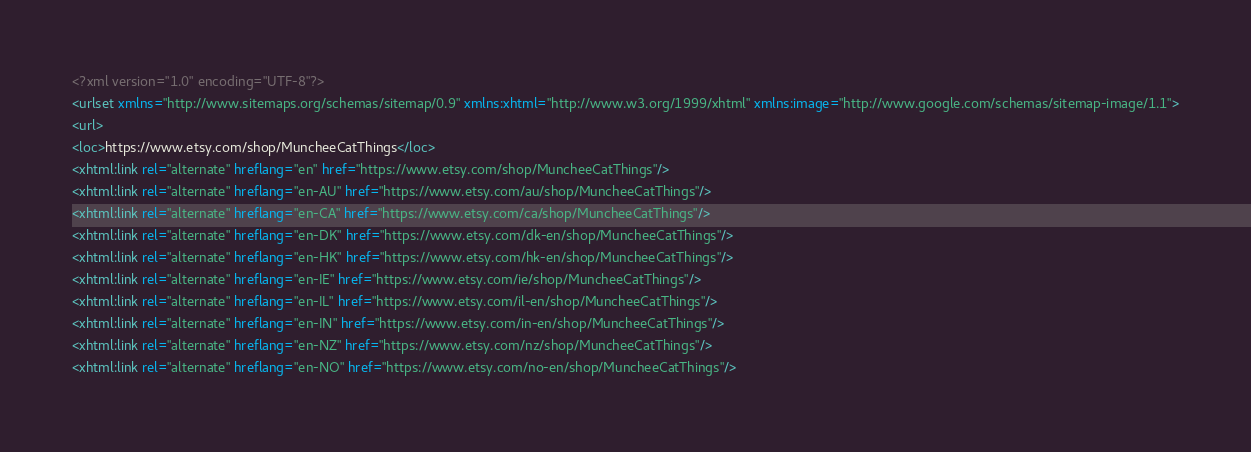Convert code to text. <code><loc_0><loc_0><loc_500><loc_500><_XML_><?xml version="1.0" encoding="UTF-8"?>
<urlset xmlns="http://www.sitemaps.org/schemas/sitemap/0.9" xmlns:xhtml="http://www.w3.org/1999/xhtml" xmlns:image="http://www.google.com/schemas/sitemap-image/1.1">
<url>
<loc>https://www.etsy.com/shop/MuncheeCatThings</loc>
<xhtml:link rel="alternate" hreflang="en" href="https://www.etsy.com/shop/MuncheeCatThings"/>
<xhtml:link rel="alternate" hreflang="en-AU" href="https://www.etsy.com/au/shop/MuncheeCatThings"/>
<xhtml:link rel="alternate" hreflang="en-CA" href="https://www.etsy.com/ca/shop/MuncheeCatThings"/>
<xhtml:link rel="alternate" hreflang="en-DK" href="https://www.etsy.com/dk-en/shop/MuncheeCatThings"/>
<xhtml:link rel="alternate" hreflang="en-HK" href="https://www.etsy.com/hk-en/shop/MuncheeCatThings"/>
<xhtml:link rel="alternate" hreflang="en-IE" href="https://www.etsy.com/ie/shop/MuncheeCatThings"/>
<xhtml:link rel="alternate" hreflang="en-IL" href="https://www.etsy.com/il-en/shop/MuncheeCatThings"/>
<xhtml:link rel="alternate" hreflang="en-IN" href="https://www.etsy.com/in-en/shop/MuncheeCatThings"/>
<xhtml:link rel="alternate" hreflang="en-NZ" href="https://www.etsy.com/nz/shop/MuncheeCatThings"/>
<xhtml:link rel="alternate" hreflang="en-NO" href="https://www.etsy.com/no-en/shop/MuncheeCatThings"/></code> 